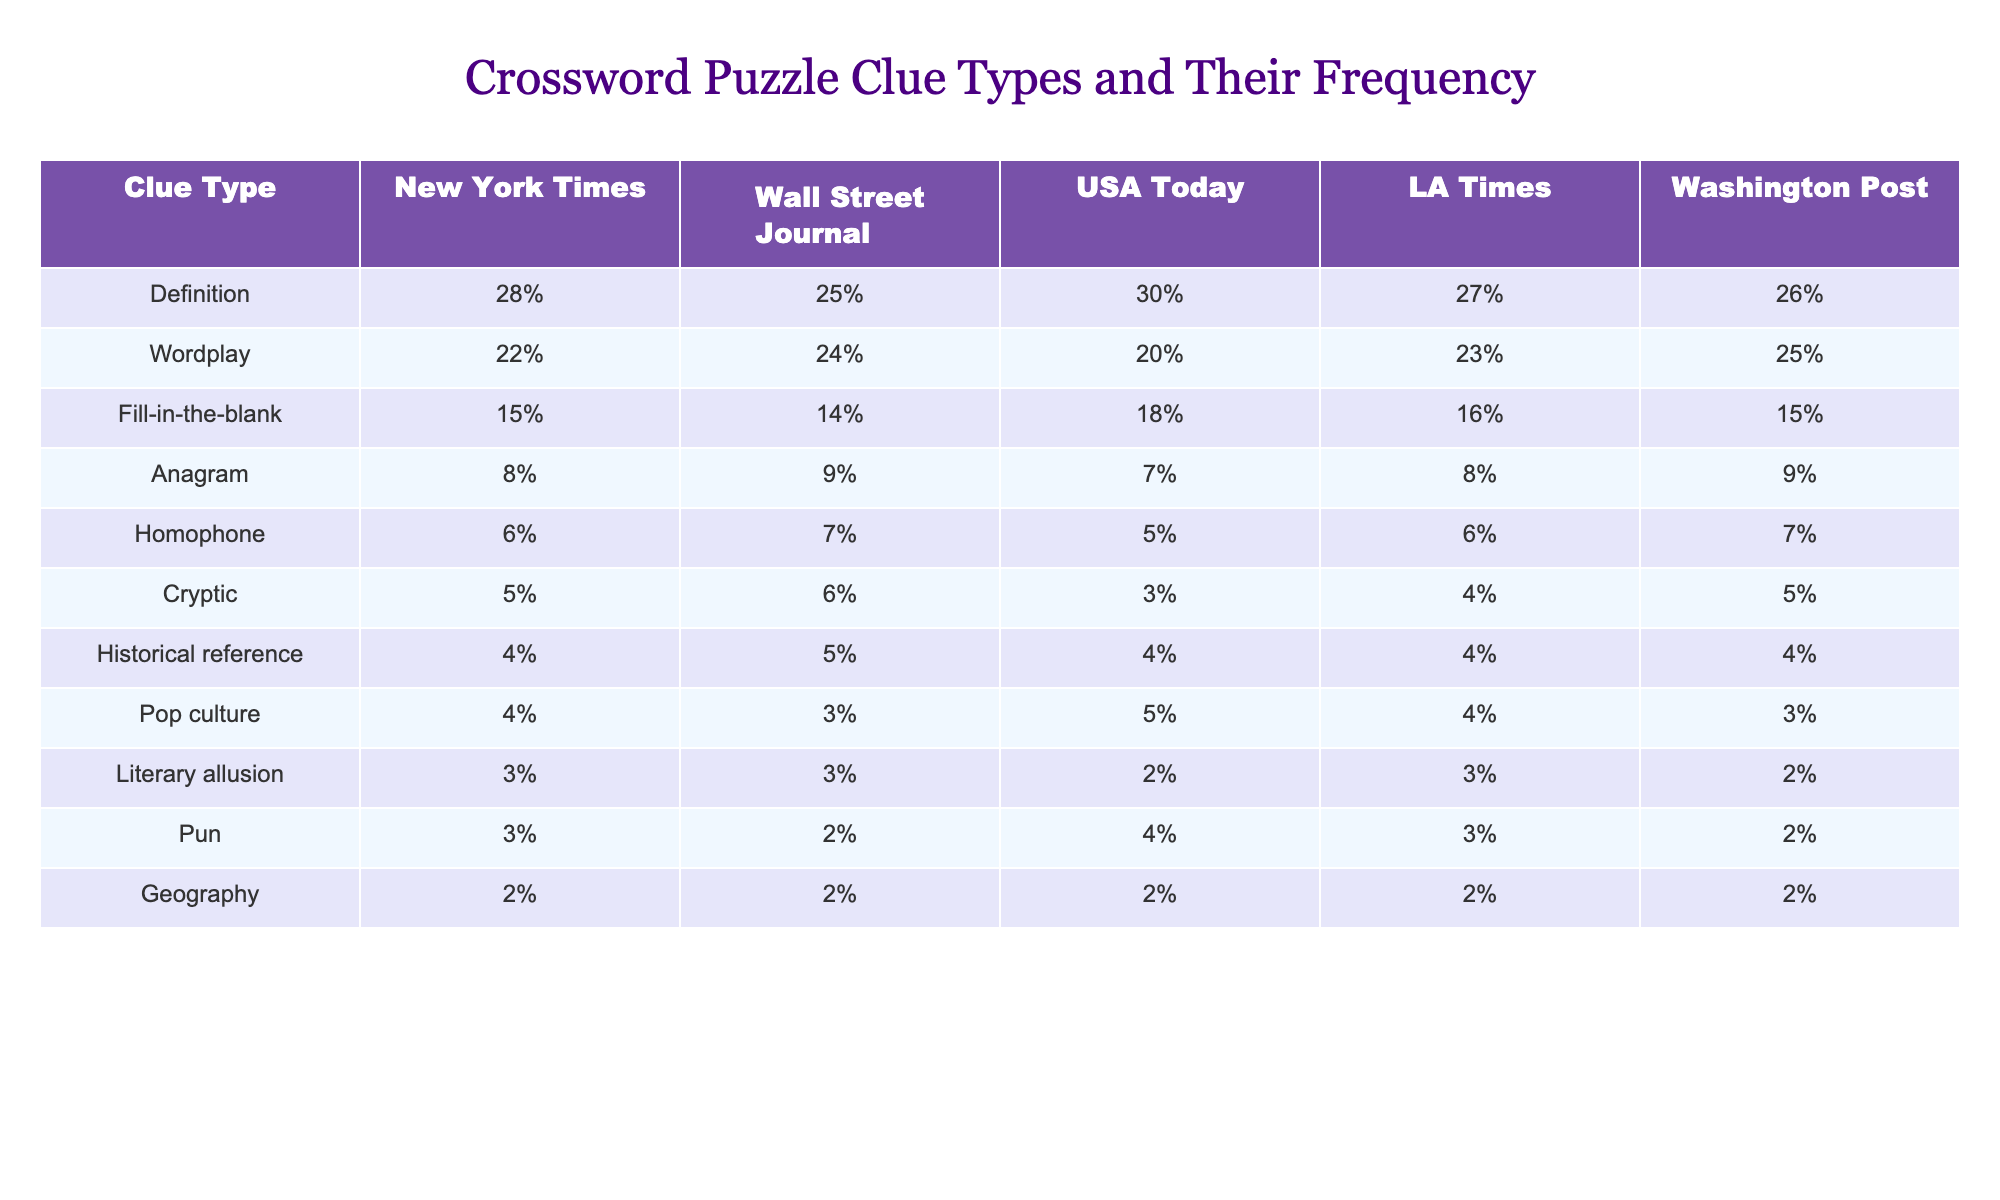What clue type has the highest percentage in the New York Times? The highest percentage in the New York Times is for the Definition clue type, which is 28%.
Answer: Definition Which newspaper has the lowest frequency of Anagram clues? The USA Today has the lowest frequency of Anagram clues at 7%.
Answer: USA Today What is the average percentage of Wordplay clues across all newspapers listed? The percentages of Wordplay clues are 22%, 24%, 20%, 23%, and 25%. The sum is 24% (average = (22+24+20+23+25)/5).
Answer: 24% Is the frequency of Geography clues the same across all newspapers? No, every newspaper has the same frequency of Geography clues at 2%.
Answer: Yes Which clue type is most commonly associated with historical references? Historical references have a frequency of 4% in all newspapers. This is the same across those that reference it.
Answer: 4% How does the frequency of Cryptic clues compare between the New York Times and the Wall Street Journal? The New York Times has 5% frequency and the Wall Street Journal has 6%. Therefore, the Wall Street Journal has a slightly higher frequency than the New York Times.
Answer: Wall Street Journal What is the difference in frequency between Definition and Fill-in-the-blank clues in USA Today? Definition clues have a frequency of 30% while Fill-in-the-blank clues have a frequency of 18%. The difference is 12% (30% - 18%).
Answer: 12% In which newspaper is Wordplay clues’ frequency greater than Pop culture clues? In the New York Times, Wall Street Journal, and LA Times, Wordplay clues (22%, 24%, and 23%, respectively) are more frequent than Pop culture clues (4%, 3%, and 4%, respectively).
Answer: New York Times, Wall Street Journal, LA Times How many total different clue types are presented in the table? There are 12 different clue types listed in the table for all newspapers.
Answer: 12 Which two newspapers have the same frequency for Homophone clues? The New York Times and Wall Street Journal both have a frequency of 7% for Homophone clues.
Answer: New York Times and Wall Street Journal 